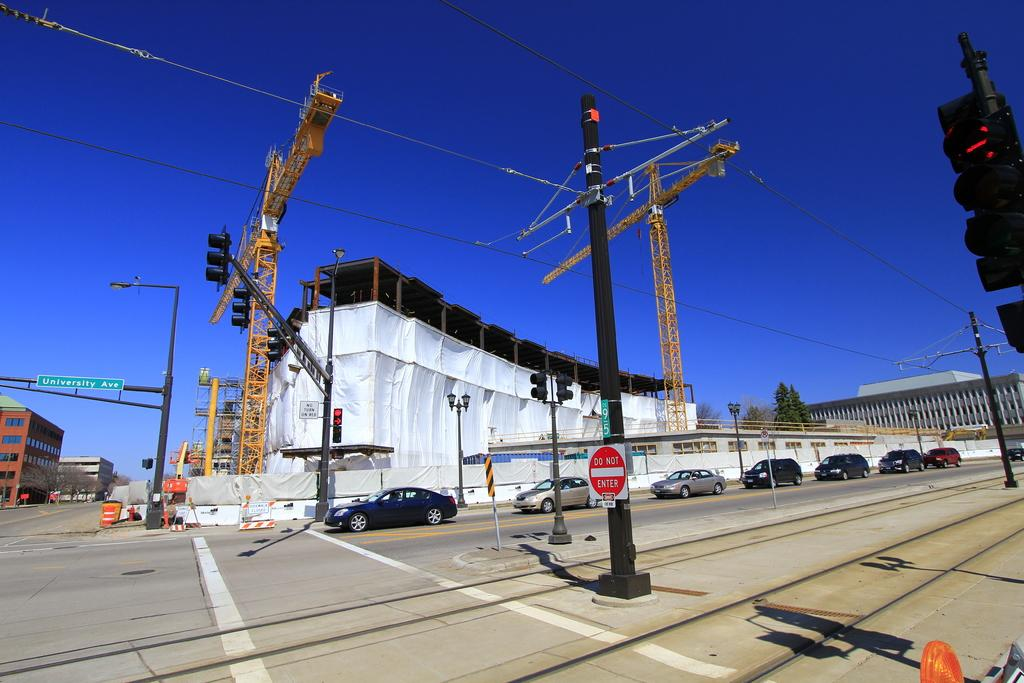Provide a one-sentence caption for the provided image. building construction at intersection of roads, one is university avenue. 